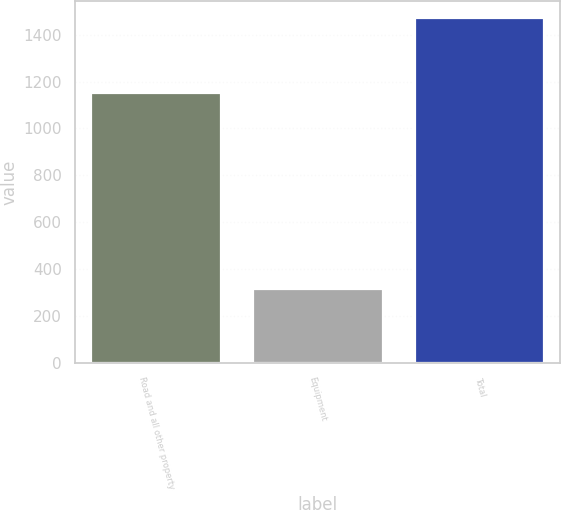Convert chart. <chart><loc_0><loc_0><loc_500><loc_500><bar_chart><fcel>Road and all other property<fcel>Equipment<fcel>Total<nl><fcel>1153<fcel>317<fcel>1470<nl></chart> 